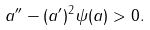Convert formula to latex. <formula><loc_0><loc_0><loc_500><loc_500>a ^ { \prime \prime } - ( a ^ { \prime } ) ^ { 2 } \psi ( a ) > 0 .</formula> 